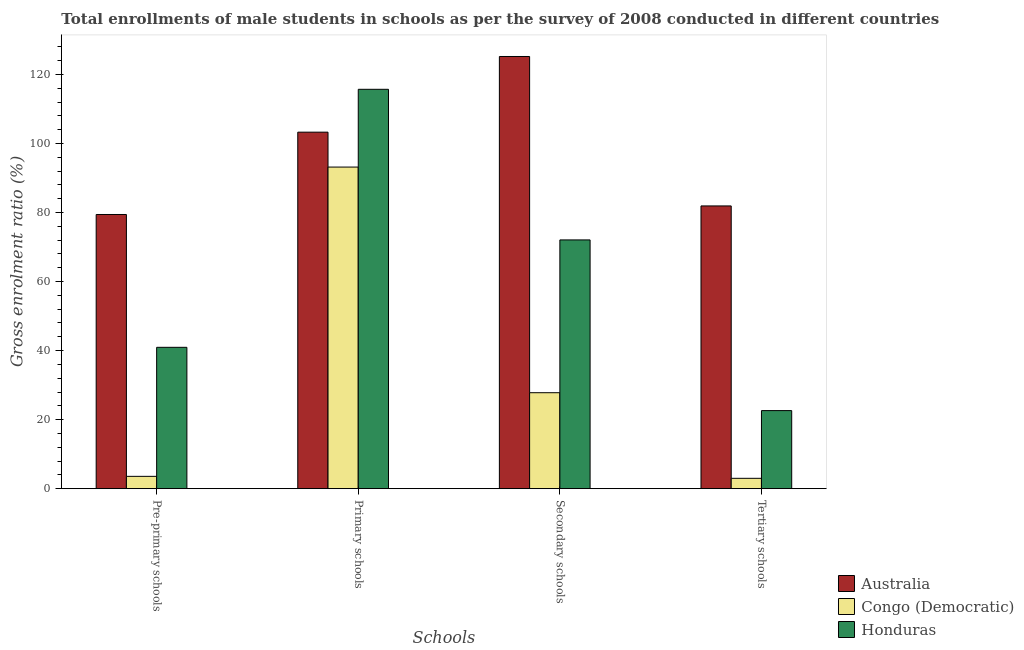How many different coloured bars are there?
Ensure brevity in your answer.  3. How many groups of bars are there?
Offer a terse response. 4. Are the number of bars per tick equal to the number of legend labels?
Your answer should be compact. Yes. Are the number of bars on each tick of the X-axis equal?
Offer a very short reply. Yes. How many bars are there on the 3rd tick from the right?
Give a very brief answer. 3. What is the label of the 1st group of bars from the left?
Keep it short and to the point. Pre-primary schools. What is the gross enrolment ratio(male) in secondary schools in Australia?
Provide a short and direct response. 125.19. Across all countries, what is the maximum gross enrolment ratio(male) in tertiary schools?
Offer a terse response. 81.9. Across all countries, what is the minimum gross enrolment ratio(male) in primary schools?
Your response must be concise. 93.16. In which country was the gross enrolment ratio(male) in secondary schools maximum?
Ensure brevity in your answer.  Australia. In which country was the gross enrolment ratio(male) in pre-primary schools minimum?
Make the answer very short. Congo (Democratic). What is the total gross enrolment ratio(male) in pre-primary schools in the graph?
Your answer should be very brief. 123.94. What is the difference between the gross enrolment ratio(male) in primary schools in Honduras and that in Congo (Democratic)?
Keep it short and to the point. 22.53. What is the difference between the gross enrolment ratio(male) in tertiary schools in Honduras and the gross enrolment ratio(male) in secondary schools in Congo (Democratic)?
Give a very brief answer. -5.18. What is the average gross enrolment ratio(male) in secondary schools per country?
Provide a short and direct response. 75.02. What is the difference between the gross enrolment ratio(male) in secondary schools and gross enrolment ratio(male) in pre-primary schools in Congo (Democratic)?
Give a very brief answer. 24.23. In how many countries, is the gross enrolment ratio(male) in tertiary schools greater than 24 %?
Offer a terse response. 1. What is the ratio of the gross enrolment ratio(male) in secondary schools in Congo (Democratic) to that in Honduras?
Offer a terse response. 0.39. Is the difference between the gross enrolment ratio(male) in tertiary schools in Honduras and Congo (Democratic) greater than the difference between the gross enrolment ratio(male) in pre-primary schools in Honduras and Congo (Democratic)?
Make the answer very short. No. What is the difference between the highest and the second highest gross enrolment ratio(male) in secondary schools?
Your answer should be very brief. 53.14. What is the difference between the highest and the lowest gross enrolment ratio(male) in secondary schools?
Ensure brevity in your answer.  97.4. In how many countries, is the gross enrolment ratio(male) in pre-primary schools greater than the average gross enrolment ratio(male) in pre-primary schools taken over all countries?
Make the answer very short. 1. What does the 1st bar from the left in Primary schools represents?
Offer a very short reply. Australia. Is it the case that in every country, the sum of the gross enrolment ratio(male) in pre-primary schools and gross enrolment ratio(male) in primary schools is greater than the gross enrolment ratio(male) in secondary schools?
Offer a terse response. Yes. Are all the bars in the graph horizontal?
Provide a short and direct response. No. What is the difference between two consecutive major ticks on the Y-axis?
Your answer should be compact. 20. Are the values on the major ticks of Y-axis written in scientific E-notation?
Your answer should be compact. No. Does the graph contain any zero values?
Your answer should be compact. No. Does the graph contain grids?
Provide a succinct answer. No. How many legend labels are there?
Keep it short and to the point. 3. How are the legend labels stacked?
Offer a very short reply. Vertical. What is the title of the graph?
Provide a short and direct response. Total enrollments of male students in schools as per the survey of 2008 conducted in different countries. What is the label or title of the X-axis?
Ensure brevity in your answer.  Schools. What is the Gross enrolment ratio (%) in Australia in Pre-primary schools?
Provide a short and direct response. 79.42. What is the Gross enrolment ratio (%) of Congo (Democratic) in Pre-primary schools?
Offer a very short reply. 3.57. What is the Gross enrolment ratio (%) in Honduras in Pre-primary schools?
Offer a very short reply. 40.95. What is the Gross enrolment ratio (%) in Australia in Primary schools?
Give a very brief answer. 103.27. What is the Gross enrolment ratio (%) in Congo (Democratic) in Primary schools?
Give a very brief answer. 93.16. What is the Gross enrolment ratio (%) in Honduras in Primary schools?
Make the answer very short. 115.69. What is the Gross enrolment ratio (%) of Australia in Secondary schools?
Keep it short and to the point. 125.19. What is the Gross enrolment ratio (%) of Congo (Democratic) in Secondary schools?
Offer a terse response. 27.8. What is the Gross enrolment ratio (%) in Honduras in Secondary schools?
Your answer should be compact. 72.06. What is the Gross enrolment ratio (%) of Australia in Tertiary schools?
Offer a terse response. 81.9. What is the Gross enrolment ratio (%) in Congo (Democratic) in Tertiary schools?
Your answer should be compact. 3. What is the Gross enrolment ratio (%) of Honduras in Tertiary schools?
Offer a very short reply. 22.62. Across all Schools, what is the maximum Gross enrolment ratio (%) in Australia?
Your answer should be compact. 125.19. Across all Schools, what is the maximum Gross enrolment ratio (%) of Congo (Democratic)?
Your answer should be compact. 93.16. Across all Schools, what is the maximum Gross enrolment ratio (%) in Honduras?
Provide a succinct answer. 115.69. Across all Schools, what is the minimum Gross enrolment ratio (%) of Australia?
Provide a short and direct response. 79.42. Across all Schools, what is the minimum Gross enrolment ratio (%) in Congo (Democratic)?
Ensure brevity in your answer.  3. Across all Schools, what is the minimum Gross enrolment ratio (%) of Honduras?
Your answer should be very brief. 22.62. What is the total Gross enrolment ratio (%) of Australia in the graph?
Provide a succinct answer. 389.79. What is the total Gross enrolment ratio (%) in Congo (Democratic) in the graph?
Offer a terse response. 127.52. What is the total Gross enrolment ratio (%) of Honduras in the graph?
Give a very brief answer. 251.31. What is the difference between the Gross enrolment ratio (%) of Australia in Pre-primary schools and that in Primary schools?
Give a very brief answer. -23.85. What is the difference between the Gross enrolment ratio (%) in Congo (Democratic) in Pre-primary schools and that in Primary schools?
Your answer should be compact. -89.59. What is the difference between the Gross enrolment ratio (%) in Honduras in Pre-primary schools and that in Primary schools?
Provide a succinct answer. -74.74. What is the difference between the Gross enrolment ratio (%) of Australia in Pre-primary schools and that in Secondary schools?
Provide a succinct answer. -45.77. What is the difference between the Gross enrolment ratio (%) in Congo (Democratic) in Pre-primary schools and that in Secondary schools?
Provide a short and direct response. -24.23. What is the difference between the Gross enrolment ratio (%) of Honduras in Pre-primary schools and that in Secondary schools?
Your answer should be compact. -31.11. What is the difference between the Gross enrolment ratio (%) of Australia in Pre-primary schools and that in Tertiary schools?
Offer a very short reply. -2.48. What is the difference between the Gross enrolment ratio (%) of Congo (Democratic) in Pre-primary schools and that in Tertiary schools?
Provide a short and direct response. 0.57. What is the difference between the Gross enrolment ratio (%) of Honduras in Pre-primary schools and that in Tertiary schools?
Your response must be concise. 18.33. What is the difference between the Gross enrolment ratio (%) in Australia in Primary schools and that in Secondary schools?
Ensure brevity in your answer.  -21.92. What is the difference between the Gross enrolment ratio (%) of Congo (Democratic) in Primary schools and that in Secondary schools?
Keep it short and to the point. 65.36. What is the difference between the Gross enrolment ratio (%) in Honduras in Primary schools and that in Secondary schools?
Your response must be concise. 43.63. What is the difference between the Gross enrolment ratio (%) of Australia in Primary schools and that in Tertiary schools?
Your response must be concise. 21.37. What is the difference between the Gross enrolment ratio (%) in Congo (Democratic) in Primary schools and that in Tertiary schools?
Your answer should be compact. 90.16. What is the difference between the Gross enrolment ratio (%) in Honduras in Primary schools and that in Tertiary schools?
Offer a very short reply. 93.07. What is the difference between the Gross enrolment ratio (%) in Australia in Secondary schools and that in Tertiary schools?
Keep it short and to the point. 43.29. What is the difference between the Gross enrolment ratio (%) in Congo (Democratic) in Secondary schools and that in Tertiary schools?
Offer a terse response. 24.8. What is the difference between the Gross enrolment ratio (%) in Honduras in Secondary schools and that in Tertiary schools?
Your answer should be compact. 49.44. What is the difference between the Gross enrolment ratio (%) of Australia in Pre-primary schools and the Gross enrolment ratio (%) of Congo (Democratic) in Primary schools?
Give a very brief answer. -13.74. What is the difference between the Gross enrolment ratio (%) of Australia in Pre-primary schools and the Gross enrolment ratio (%) of Honduras in Primary schools?
Provide a short and direct response. -36.26. What is the difference between the Gross enrolment ratio (%) in Congo (Democratic) in Pre-primary schools and the Gross enrolment ratio (%) in Honduras in Primary schools?
Keep it short and to the point. -112.12. What is the difference between the Gross enrolment ratio (%) of Australia in Pre-primary schools and the Gross enrolment ratio (%) of Congo (Democratic) in Secondary schools?
Make the answer very short. 51.62. What is the difference between the Gross enrolment ratio (%) in Australia in Pre-primary schools and the Gross enrolment ratio (%) in Honduras in Secondary schools?
Keep it short and to the point. 7.36. What is the difference between the Gross enrolment ratio (%) of Congo (Democratic) in Pre-primary schools and the Gross enrolment ratio (%) of Honduras in Secondary schools?
Offer a very short reply. -68.49. What is the difference between the Gross enrolment ratio (%) in Australia in Pre-primary schools and the Gross enrolment ratio (%) in Congo (Democratic) in Tertiary schools?
Your answer should be compact. 76.42. What is the difference between the Gross enrolment ratio (%) of Australia in Pre-primary schools and the Gross enrolment ratio (%) of Honduras in Tertiary schools?
Give a very brief answer. 56.81. What is the difference between the Gross enrolment ratio (%) of Congo (Democratic) in Pre-primary schools and the Gross enrolment ratio (%) of Honduras in Tertiary schools?
Your answer should be very brief. -19.05. What is the difference between the Gross enrolment ratio (%) in Australia in Primary schools and the Gross enrolment ratio (%) in Congo (Democratic) in Secondary schools?
Provide a succinct answer. 75.47. What is the difference between the Gross enrolment ratio (%) of Australia in Primary schools and the Gross enrolment ratio (%) of Honduras in Secondary schools?
Offer a terse response. 31.21. What is the difference between the Gross enrolment ratio (%) in Congo (Democratic) in Primary schools and the Gross enrolment ratio (%) in Honduras in Secondary schools?
Your answer should be compact. 21.1. What is the difference between the Gross enrolment ratio (%) in Australia in Primary schools and the Gross enrolment ratio (%) in Congo (Democratic) in Tertiary schools?
Ensure brevity in your answer.  100.27. What is the difference between the Gross enrolment ratio (%) in Australia in Primary schools and the Gross enrolment ratio (%) in Honduras in Tertiary schools?
Your response must be concise. 80.66. What is the difference between the Gross enrolment ratio (%) in Congo (Democratic) in Primary schools and the Gross enrolment ratio (%) in Honduras in Tertiary schools?
Your response must be concise. 70.54. What is the difference between the Gross enrolment ratio (%) in Australia in Secondary schools and the Gross enrolment ratio (%) in Congo (Democratic) in Tertiary schools?
Your answer should be compact. 122.2. What is the difference between the Gross enrolment ratio (%) of Australia in Secondary schools and the Gross enrolment ratio (%) of Honduras in Tertiary schools?
Your answer should be very brief. 102.58. What is the difference between the Gross enrolment ratio (%) of Congo (Democratic) in Secondary schools and the Gross enrolment ratio (%) of Honduras in Tertiary schools?
Your answer should be very brief. 5.18. What is the average Gross enrolment ratio (%) in Australia per Schools?
Provide a succinct answer. 97.45. What is the average Gross enrolment ratio (%) in Congo (Democratic) per Schools?
Offer a terse response. 31.88. What is the average Gross enrolment ratio (%) in Honduras per Schools?
Your answer should be very brief. 62.83. What is the difference between the Gross enrolment ratio (%) in Australia and Gross enrolment ratio (%) in Congo (Democratic) in Pre-primary schools?
Your response must be concise. 75.85. What is the difference between the Gross enrolment ratio (%) in Australia and Gross enrolment ratio (%) in Honduras in Pre-primary schools?
Your answer should be very brief. 38.48. What is the difference between the Gross enrolment ratio (%) of Congo (Democratic) and Gross enrolment ratio (%) of Honduras in Pre-primary schools?
Ensure brevity in your answer.  -37.38. What is the difference between the Gross enrolment ratio (%) in Australia and Gross enrolment ratio (%) in Congo (Democratic) in Primary schools?
Offer a terse response. 10.11. What is the difference between the Gross enrolment ratio (%) of Australia and Gross enrolment ratio (%) of Honduras in Primary schools?
Your answer should be compact. -12.41. What is the difference between the Gross enrolment ratio (%) in Congo (Democratic) and Gross enrolment ratio (%) in Honduras in Primary schools?
Your answer should be compact. -22.53. What is the difference between the Gross enrolment ratio (%) of Australia and Gross enrolment ratio (%) of Congo (Democratic) in Secondary schools?
Your answer should be very brief. 97.4. What is the difference between the Gross enrolment ratio (%) of Australia and Gross enrolment ratio (%) of Honduras in Secondary schools?
Make the answer very short. 53.14. What is the difference between the Gross enrolment ratio (%) in Congo (Democratic) and Gross enrolment ratio (%) in Honduras in Secondary schools?
Make the answer very short. -44.26. What is the difference between the Gross enrolment ratio (%) in Australia and Gross enrolment ratio (%) in Congo (Democratic) in Tertiary schools?
Provide a short and direct response. 78.91. What is the difference between the Gross enrolment ratio (%) in Australia and Gross enrolment ratio (%) in Honduras in Tertiary schools?
Offer a very short reply. 59.29. What is the difference between the Gross enrolment ratio (%) of Congo (Democratic) and Gross enrolment ratio (%) of Honduras in Tertiary schools?
Offer a very short reply. -19.62. What is the ratio of the Gross enrolment ratio (%) of Australia in Pre-primary schools to that in Primary schools?
Your answer should be compact. 0.77. What is the ratio of the Gross enrolment ratio (%) of Congo (Democratic) in Pre-primary schools to that in Primary schools?
Give a very brief answer. 0.04. What is the ratio of the Gross enrolment ratio (%) in Honduras in Pre-primary schools to that in Primary schools?
Your answer should be compact. 0.35. What is the ratio of the Gross enrolment ratio (%) of Australia in Pre-primary schools to that in Secondary schools?
Make the answer very short. 0.63. What is the ratio of the Gross enrolment ratio (%) in Congo (Democratic) in Pre-primary schools to that in Secondary schools?
Offer a terse response. 0.13. What is the ratio of the Gross enrolment ratio (%) of Honduras in Pre-primary schools to that in Secondary schools?
Keep it short and to the point. 0.57. What is the ratio of the Gross enrolment ratio (%) of Australia in Pre-primary schools to that in Tertiary schools?
Your answer should be compact. 0.97. What is the ratio of the Gross enrolment ratio (%) in Congo (Democratic) in Pre-primary schools to that in Tertiary schools?
Ensure brevity in your answer.  1.19. What is the ratio of the Gross enrolment ratio (%) in Honduras in Pre-primary schools to that in Tertiary schools?
Provide a succinct answer. 1.81. What is the ratio of the Gross enrolment ratio (%) of Australia in Primary schools to that in Secondary schools?
Provide a succinct answer. 0.82. What is the ratio of the Gross enrolment ratio (%) of Congo (Democratic) in Primary schools to that in Secondary schools?
Give a very brief answer. 3.35. What is the ratio of the Gross enrolment ratio (%) of Honduras in Primary schools to that in Secondary schools?
Give a very brief answer. 1.61. What is the ratio of the Gross enrolment ratio (%) in Australia in Primary schools to that in Tertiary schools?
Your answer should be very brief. 1.26. What is the ratio of the Gross enrolment ratio (%) in Congo (Democratic) in Primary schools to that in Tertiary schools?
Provide a succinct answer. 31.07. What is the ratio of the Gross enrolment ratio (%) of Honduras in Primary schools to that in Tertiary schools?
Ensure brevity in your answer.  5.12. What is the ratio of the Gross enrolment ratio (%) in Australia in Secondary schools to that in Tertiary schools?
Your answer should be very brief. 1.53. What is the ratio of the Gross enrolment ratio (%) of Congo (Democratic) in Secondary schools to that in Tertiary schools?
Offer a terse response. 9.27. What is the ratio of the Gross enrolment ratio (%) in Honduras in Secondary schools to that in Tertiary schools?
Keep it short and to the point. 3.19. What is the difference between the highest and the second highest Gross enrolment ratio (%) in Australia?
Provide a short and direct response. 21.92. What is the difference between the highest and the second highest Gross enrolment ratio (%) in Congo (Democratic)?
Provide a short and direct response. 65.36. What is the difference between the highest and the second highest Gross enrolment ratio (%) of Honduras?
Give a very brief answer. 43.63. What is the difference between the highest and the lowest Gross enrolment ratio (%) of Australia?
Provide a succinct answer. 45.77. What is the difference between the highest and the lowest Gross enrolment ratio (%) of Congo (Democratic)?
Your answer should be very brief. 90.16. What is the difference between the highest and the lowest Gross enrolment ratio (%) in Honduras?
Your answer should be very brief. 93.07. 